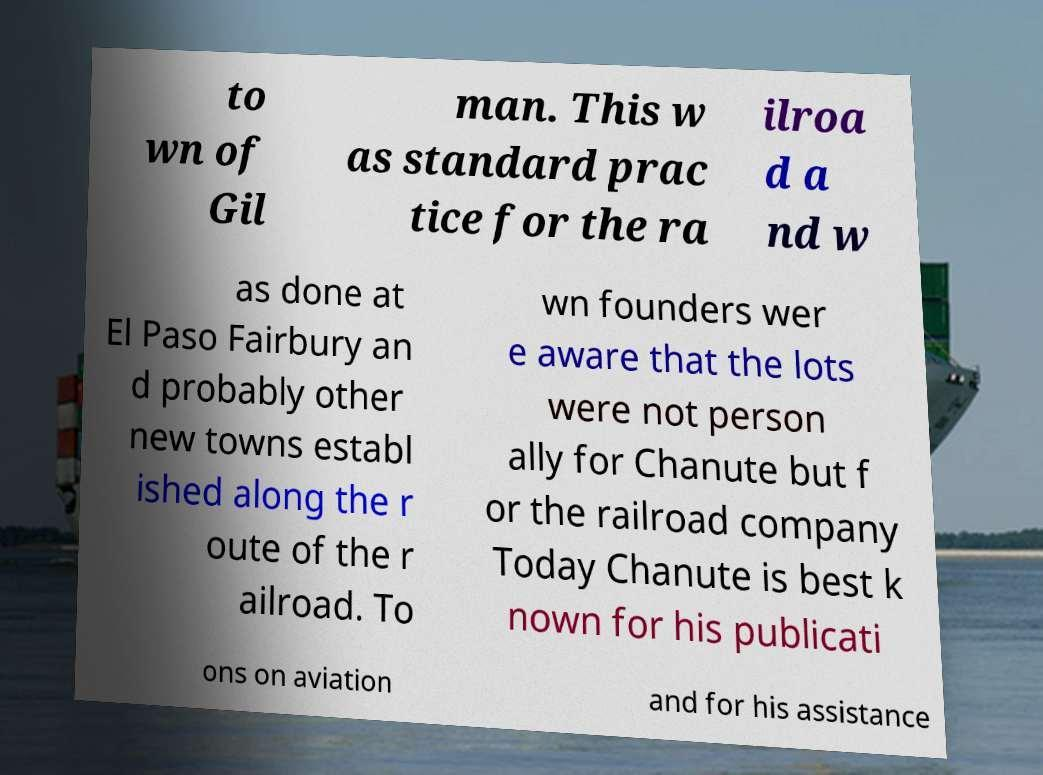Can you accurately transcribe the text from the provided image for me? to wn of Gil man. This w as standard prac tice for the ra ilroa d a nd w as done at El Paso Fairbury an d probably other new towns establ ished along the r oute of the r ailroad. To wn founders wer e aware that the lots were not person ally for Chanute but f or the railroad company Today Chanute is best k nown for his publicati ons on aviation and for his assistance 